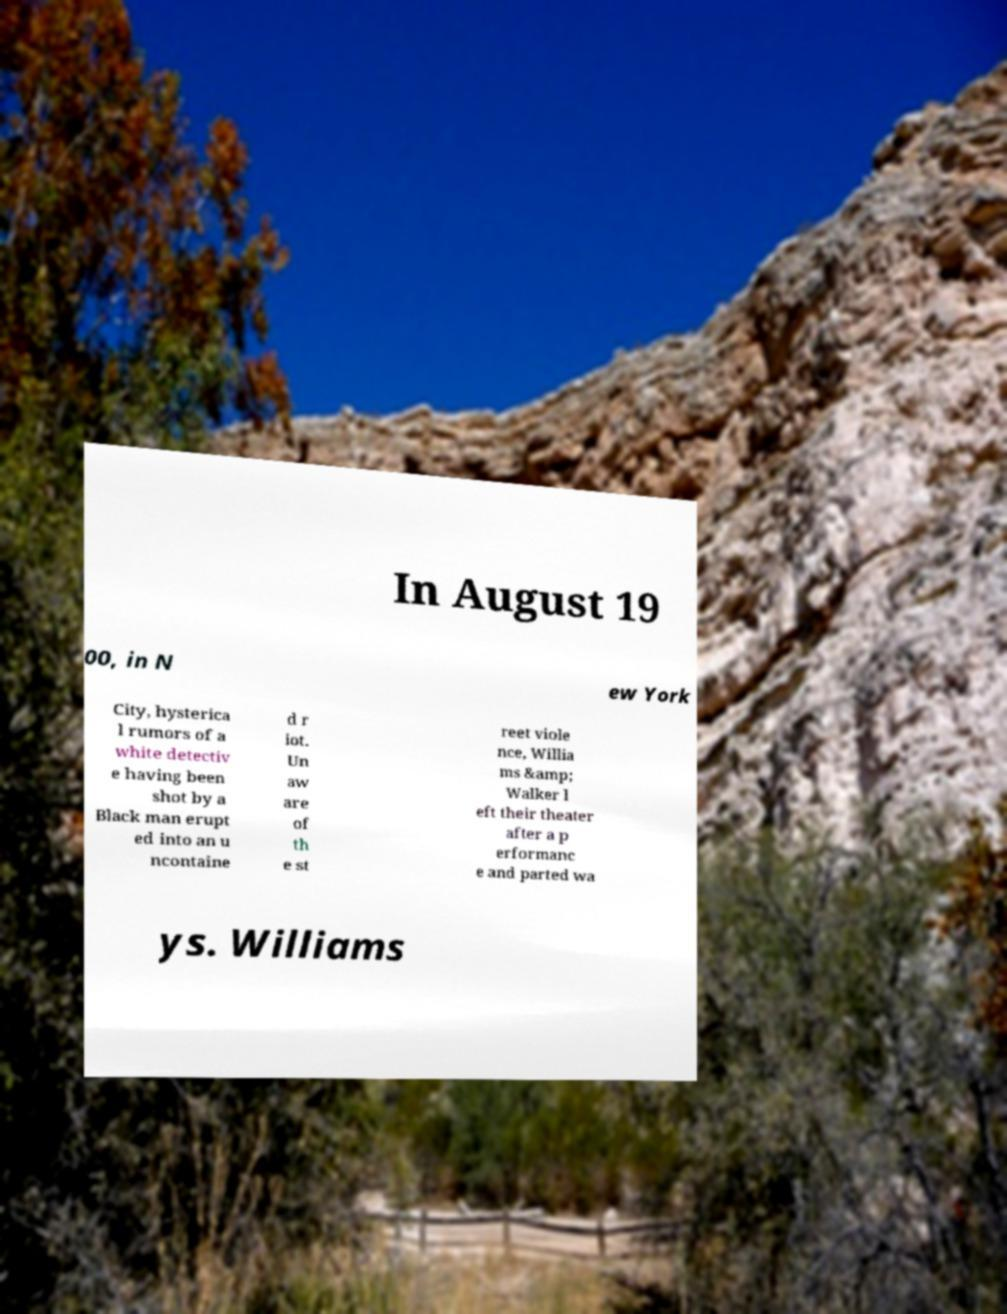Please identify and transcribe the text found in this image. In August 19 00, in N ew York City, hysterica l rumors of a white detectiv e having been shot by a Black man erupt ed into an u ncontaine d r iot. Un aw are of th e st reet viole nce, Willia ms &amp; Walker l eft their theater after a p erformanc e and parted wa ys. Williams 